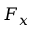Convert formula to latex. <formula><loc_0><loc_0><loc_500><loc_500>F _ { x }</formula> 